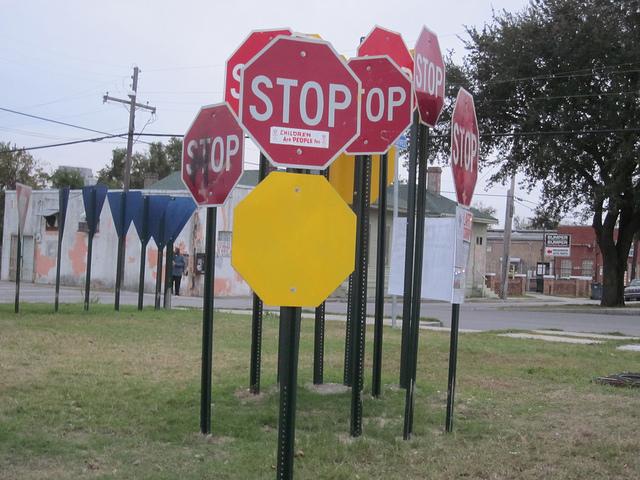Are all the signs red?
Short answer required. No. How many stop signs are there?
Quick response, please. 7. Has the grass been mowed recently?
Answer briefly. Yes. How many stops signs are in the picture?
Answer briefly. 7. 